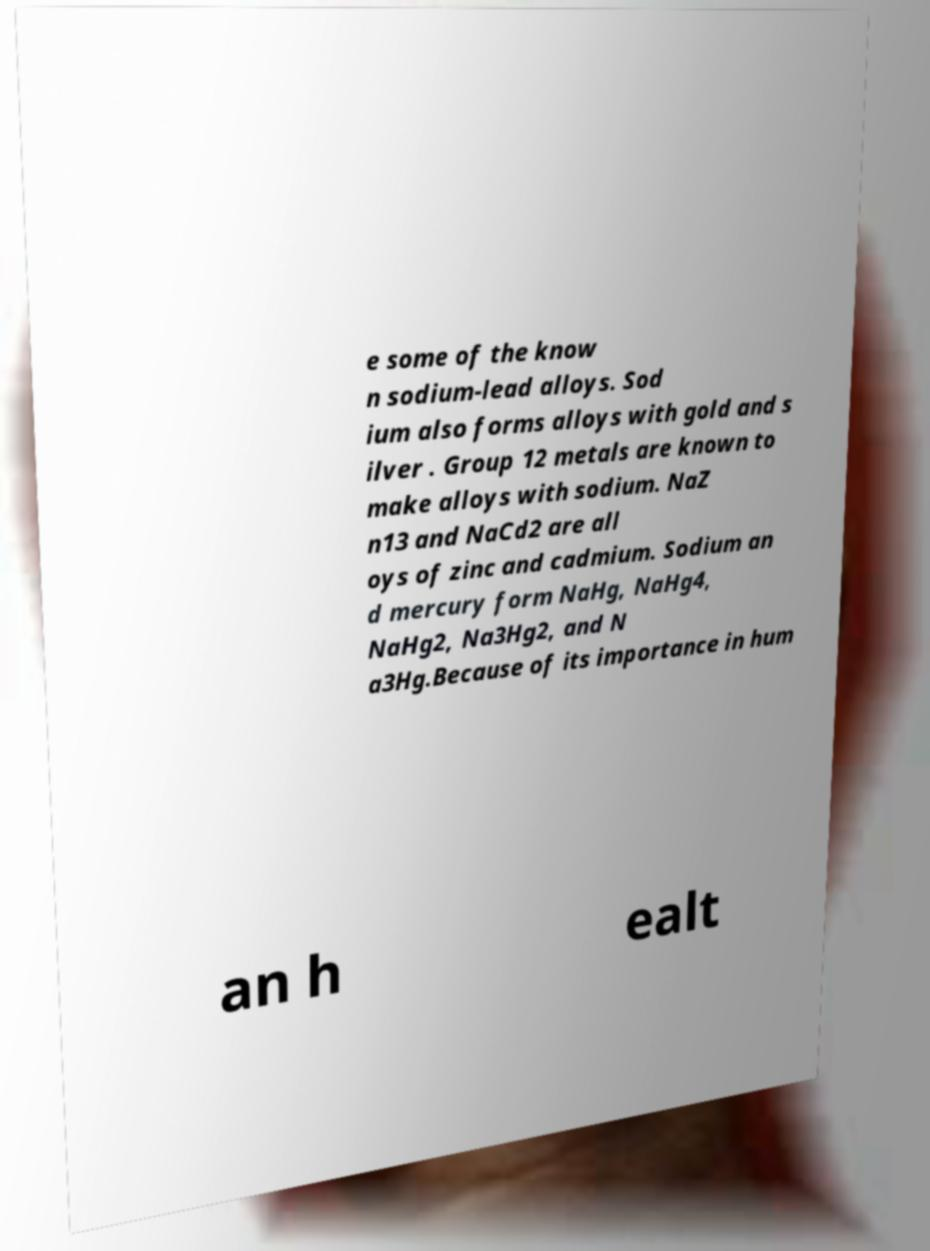Can you read and provide the text displayed in the image?This photo seems to have some interesting text. Can you extract and type it out for me? e some of the know n sodium-lead alloys. Sod ium also forms alloys with gold and s ilver . Group 12 metals are known to make alloys with sodium. NaZ n13 and NaCd2 are all oys of zinc and cadmium. Sodium an d mercury form NaHg, NaHg4, NaHg2, Na3Hg2, and N a3Hg.Because of its importance in hum an h ealt 